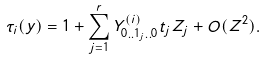<formula> <loc_0><loc_0><loc_500><loc_500>\tau _ { i } ( y ) = 1 + \sum _ { j = 1 } ^ { r } Y _ { 0 . . 1 _ { j } . . 0 } ^ { ( i ) } t _ { j } Z _ { j } + O ( Z ^ { 2 } ) .</formula> 